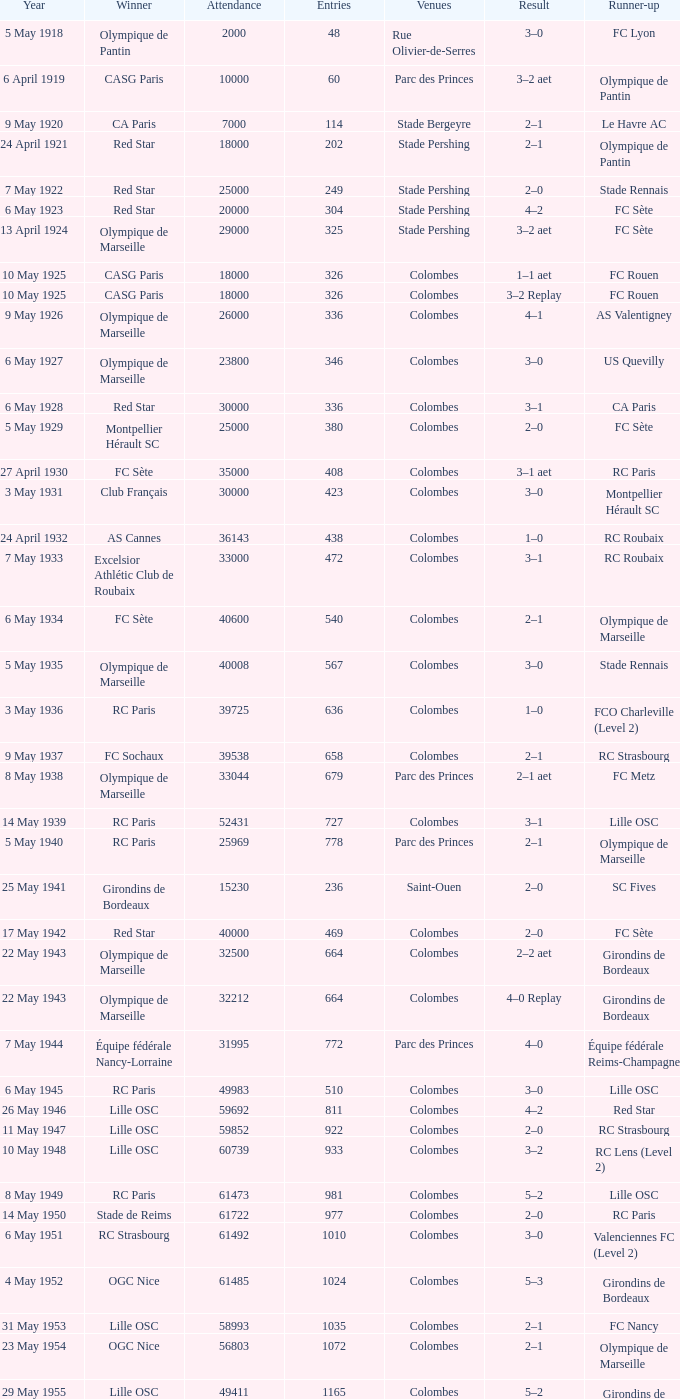What is the fewest recorded entrants against paris saint-germain? 6394.0. Can you give me this table as a dict? {'header': ['Year', 'Winner', 'Attendance', 'Entries', 'Venues', 'Result', 'Runner-up'], 'rows': [['5 May 1918', 'Olympique de Pantin', '2000', '48', 'Rue Olivier-de-Serres', '3–0', 'FC Lyon'], ['6 April 1919', 'CASG Paris', '10000', '60', 'Parc des Princes', '3–2 aet', 'Olympique de Pantin'], ['9 May 1920', 'CA Paris', '7000', '114', 'Stade Bergeyre', '2–1', 'Le Havre AC'], ['24 April 1921', 'Red Star', '18000', '202', 'Stade Pershing', '2–1', 'Olympique de Pantin'], ['7 May 1922', 'Red Star', '25000', '249', 'Stade Pershing', '2–0', 'Stade Rennais'], ['6 May 1923', 'Red Star', '20000', '304', 'Stade Pershing', '4–2', 'FC Sète'], ['13 April 1924', 'Olympique de Marseille', '29000', '325', 'Stade Pershing', '3–2 aet', 'FC Sète'], ['10 May 1925', 'CASG Paris', '18000', '326', 'Colombes', '1–1 aet', 'FC Rouen'], ['10 May 1925', 'CASG Paris', '18000', '326', 'Colombes', '3–2 Replay', 'FC Rouen'], ['9 May 1926', 'Olympique de Marseille', '26000', '336', 'Colombes', '4–1', 'AS Valentigney'], ['6 May 1927', 'Olympique de Marseille', '23800', '346', 'Colombes', '3–0', 'US Quevilly'], ['6 May 1928', 'Red Star', '30000', '336', 'Colombes', '3–1', 'CA Paris'], ['5 May 1929', 'Montpellier Hérault SC', '25000', '380', 'Colombes', '2–0', 'FC Sète'], ['27 April 1930', 'FC Sète', '35000', '408', 'Colombes', '3–1 aet', 'RC Paris'], ['3 May 1931', 'Club Français', '30000', '423', 'Colombes', '3–0', 'Montpellier Hérault SC'], ['24 April 1932', 'AS Cannes', '36143', '438', 'Colombes', '1–0', 'RC Roubaix'], ['7 May 1933', 'Excelsior Athlétic Club de Roubaix', '33000', '472', 'Colombes', '3–1', 'RC Roubaix'], ['6 May 1934', 'FC Sète', '40600', '540', 'Colombes', '2–1', 'Olympique de Marseille'], ['5 May 1935', 'Olympique de Marseille', '40008', '567', 'Colombes', '3–0', 'Stade Rennais'], ['3 May 1936', 'RC Paris', '39725', '636', 'Colombes', '1–0', 'FCO Charleville (Level 2)'], ['9 May 1937', 'FC Sochaux', '39538', '658', 'Colombes', '2–1', 'RC Strasbourg'], ['8 May 1938', 'Olympique de Marseille', '33044', '679', 'Parc des Princes', '2–1 aet', 'FC Metz'], ['14 May 1939', 'RC Paris', '52431', '727', 'Colombes', '3–1', 'Lille OSC'], ['5 May 1940', 'RC Paris', '25969', '778', 'Parc des Princes', '2–1', 'Olympique de Marseille'], ['25 May 1941', 'Girondins de Bordeaux', '15230', '236', 'Saint-Ouen', '2–0', 'SC Fives'], ['17 May 1942', 'Red Star', '40000', '469', 'Colombes', '2–0', 'FC Sète'], ['22 May 1943', 'Olympique de Marseille', '32500', '664', 'Colombes', '2–2 aet', 'Girondins de Bordeaux'], ['22 May 1943', 'Olympique de Marseille', '32212', '664', 'Colombes', '4–0 Replay', 'Girondins de Bordeaux'], ['7 May 1944', 'Équipe fédérale Nancy-Lorraine', '31995', '772', 'Parc des Princes', '4–0', 'Équipe fédérale Reims-Champagne'], ['6 May 1945', 'RC Paris', '49983', '510', 'Colombes', '3–0', 'Lille OSC'], ['26 May 1946', 'Lille OSC', '59692', '811', 'Colombes', '4–2', 'Red Star'], ['11 May 1947', 'Lille OSC', '59852', '922', 'Colombes', '2–0', 'RC Strasbourg'], ['10 May 1948', 'Lille OSC', '60739', '933', 'Colombes', '3–2', 'RC Lens (Level 2)'], ['8 May 1949', 'RC Paris', '61473', '981', 'Colombes', '5–2', 'Lille OSC'], ['14 May 1950', 'Stade de Reims', '61722', '977', 'Colombes', '2–0', 'RC Paris'], ['6 May 1951', 'RC Strasbourg', '61492', '1010', 'Colombes', '3–0', 'Valenciennes FC (Level 2)'], ['4 May 1952', 'OGC Nice', '61485', '1024', 'Colombes', '5–3', 'Girondins de Bordeaux'], ['31 May 1953', 'Lille OSC', '58993', '1035', 'Colombes', '2–1', 'FC Nancy'], ['23 May 1954', 'OGC Nice', '56803', '1072', 'Colombes', '2–1', 'Olympique de Marseille'], ['29 May 1955', 'Lille OSC', '49411', '1165', 'Colombes', '5–2', 'Girondins de Bordeaux'], ['27 May 1956', 'CS Sedan', '47258', '1203', 'Colombes', '3–1', 'ES Troyes AC'], ['26 May 1957', 'Toulouse FC', '43125', '1149', 'Colombes', '6–3', 'SCO Angers'], ['18 May 1958', 'Stade de Reims', '56523', '1163', 'Colombes', '3–1', 'Nîmes Olympique'], ['18 May 1959', 'Le Havre AC (Level 2)', '36655', '1159', 'Colombes', '2–2 aet', 'FC Sochaux'], ['18 May 1959', 'Le Havre AC (Level 2)', '36655', '1159', 'Colombes', '3–0 Replay', 'FC Sochaux'], ['15 May 1960', 'AS Monaco', '38298', '1187', 'Colombes', '4–2 aet', 'AS Saint-Étienne'], ['7 May 1961', 'CS Sedan', '39070', '1193', 'Colombes', '3–1', 'Nîmes Olympique'], ['13 May 1962', 'AS Saint-Étienne', '30654', '1226', 'Colombes', '1–0', 'FC Nancy'], ['23 May 1963', 'AS Monaco', '32923', '1209', 'Colombes', '0–0 aet', 'Olympique Lyonnais'], ['23 May 1963', 'AS Monaco', '24910', '1209', 'Colombes', '2–0 Replay', 'Olympique Lyonnais'], ['10 May 1964', 'Olympique Lyonnais', '32777', '1203', 'Colombes', '2–0', 'Girondins de Bordeaux'], ['26 May 1965', 'Stade Rennais', '36789', '1183', 'Parc des Princes', '2–2 aet', 'CS Sedan'], ['26 May 1965', 'Stade Rennais', '26792', '1183', 'Parc des Princes', '3–1 Replay', 'CS Sedan'], ['22 May 1966', 'RC Strasbourg', '36285', '1190', 'Parc des Princes', '1–0', 'FC Nantes'], ['21 May 1967', 'Olympique Lyonnais', '32523', '1378', 'Parc des Princes', '3–1', 'FC Sochaux'], ['12 May 1968', 'AS Saint-Étienne', '33959', '1378', 'Colombes', '2–1', 'Girondins de Bordeaux'], ['18 May 1969', 'Olympique de Marseille', '39460', '1377', 'Colombes', '2–0', 'Girondins de Bordeaux'], ['31 May 1970', 'AS Saint-Étienne', '32894', '1375', 'Colombes', '5–0', 'FC Nantes'], ['20 June 1971', 'Stade Rennais', '46801', '1383', 'Colombes', '1–0', 'Olympique Lyonnais'], ['4 June 1972', 'Olympique de Marseille', '44069', '1596', 'Parc des Princes', '2–1', 'SC Bastia'], ['17 June 1973', 'Olympique Lyonnais', '45734', '1596', 'Parc des Princes', '2–1', 'FC Nantes'], ['8 June 1974', 'AS Saint-Étienne', '45813', '1720', 'Parc des Princes', '2–1', 'AS Monaco'], ['14 June 1975', 'AS Saint-Étienne', '44725', '1940', 'Parc des Princes', '2–0', 'RC Lens'], ['12 June 1976', 'Olympique de Marseille', '45661', '1977', 'Parc des Princes', '2–0', 'Olympique Lyonnais'], ['18 June 1977', 'AS Saint-Étienne', '45454', '2084', 'Parc des Princes', '2–1', 'Stade de Reims'], ['13 May 1978', 'AS Nancy', '45998', '2544', 'Parc des Princes', '1–0', 'OGC Nice'], ['16 June 1979', 'FC Nantes', '46070', '2473', 'Parc des Princes', '4–1 aet', 'AJ Auxerre (Level 2)'], ['7 June 1980', 'AS Monaco', '46136', '2473', 'Parc des Princes', '3–1', 'US Orléans (Level 2)'], ['13 June 1981', 'SC Bastia', '46155', '2924', 'Parc des Princes', '2–1', 'AS Saint-Étienne'], ['15 May 1982', 'Paris SG', '46160', '3179', 'Parc des Princes', '2–2 aet 6–5 pen', 'AS Saint-Étienne'], ['11 June 1983', 'Paris SG', '46203', '3280', 'Parc des Princes', '3–2', 'FC Nantes'], ['11 May 1984', 'FC Metz', '45384', '3705', 'Parc des Princes', '2–0 aet', 'AS Monaco'], ['8 June 1985', 'AS Monaco', '45711', '3983', 'Parc des Princes', '1–0', 'Paris SG'], ['30 April 1986', 'Girondins de Bordeaux', '45429', '4117', 'Parc des Princes', '2–1 aet', 'Olympique de Marseille'], ['10 June 1987', 'Girondins de Bordeaux', '45145', '4964', 'Parc des Princes', '2–0', 'Olympique de Marseille'], ['11 June 1988', 'FC Metz', '44531', '5293', 'Parc des Princes', '1–1 aet 5–4 pen', 'FC Sochaux'], ['10 June 1989', 'Olympique de Marseille', '44448', '5293', 'Parc des Princes', '4–3', 'AS Monaco'], ['2 June 1990', 'Montpellier Hérault SC', '44067', '5972', 'Parc des Princes', '2–1 aet', 'RC Paris'], ['8 June 1991', 'AS Monaco', '44123', '6065', 'Parc des Princes', '1–0', 'Olympique de Marseille'], ['12 June 1993', 'Paris SG', '48789', '6523', 'Parc des Princes', '3–0', 'FC Nantes'], ['14 May 1994', 'AJ Auxerre', '45189', '6261', 'Parc des Princes', '3–0', 'Montpellier HSC'], ['13 May 1995', 'Paris SG', '46698', '5975', 'Parc des Princes', '1–0', 'RC Strasbourg'], ['4 May 1996', 'AJ Auxerre', '44921', '5847', 'Parc des Princes', '2–1', 'Nîmes Olympique (Level 3)'], ['10 May 1997', 'OGC Nice', '44131', '5986', 'Parc des Princes', '1–1 aet 4–3 pen', 'En Avant de Guingamp'], ['2 May 1998', 'Paris SG', '78265', '6106', 'Stade de France', '2–1', 'RC Lens'], ['15 May 1999', 'FC Nantes', '78586', '5957', 'Stade de France', '1–0', 'CS Sedan (Level 2)'], ['7 May 2000', 'FC Nantes', '78717', '6096', 'Stade de France', '2–1', 'Calais RUFC (Level 4)'], ['26 May 2001', 'RC Strasbourg', '78641', '6375', 'Stade de France', '0–0 aet 5–4 pen', 'Amiens SC (Level 2)'], ['11 May 2002', 'FC Lorient', '66215', '5848', 'Stade de France', '1–0', 'SC Bastia'], ['31 May 2003', 'AJ Auxerre', '78316', '5850', 'Stade de France', '2–1', 'Paris SG'], ['29 May 2004', 'Paris SG', '78357', '6057', 'Stade de France', '1–0', 'LB Châteauroux (Level 2)'], ['4 June 2005', 'AJ Auxerre', '78721', '6263', 'Stade de France', '2–1', 'CS Sedan'], ['29 April 2006', 'Paris Saint-Germain', '79797', '6394', 'Stade de France', '2–1', 'Olympique de Marseille'], ['12 May 2007', 'FC Sochaux', '79850', '6577', 'Stade de France', '2–2 aet 5–4 pen', 'Olympique de Marseille'], ['24 May 2008', 'Olympique Lyonnais', '79204', '6734', 'Stade de France', '1–0', 'Paris Saint-Germain'], ['9 May 2009', 'EA Guingamp (Level 2)', '80056', '7246', 'Stade de France', '2–1', 'Stade Rennais'], ['1 May 2010', 'Paris Saint-Germain', '74000', '7317', 'Stade de France', '1–0 aet', 'AS Monaco'], ['14 May 2011', 'Lille', '79000', '7449', 'Stade de France', '1–0', 'Paris Saint-Germain'], ['28 April 2012', 'Olympique Lyonnais', '76293', '7422', 'Stade de France', '1–0', 'US Quevilly (Level 3)']]} 